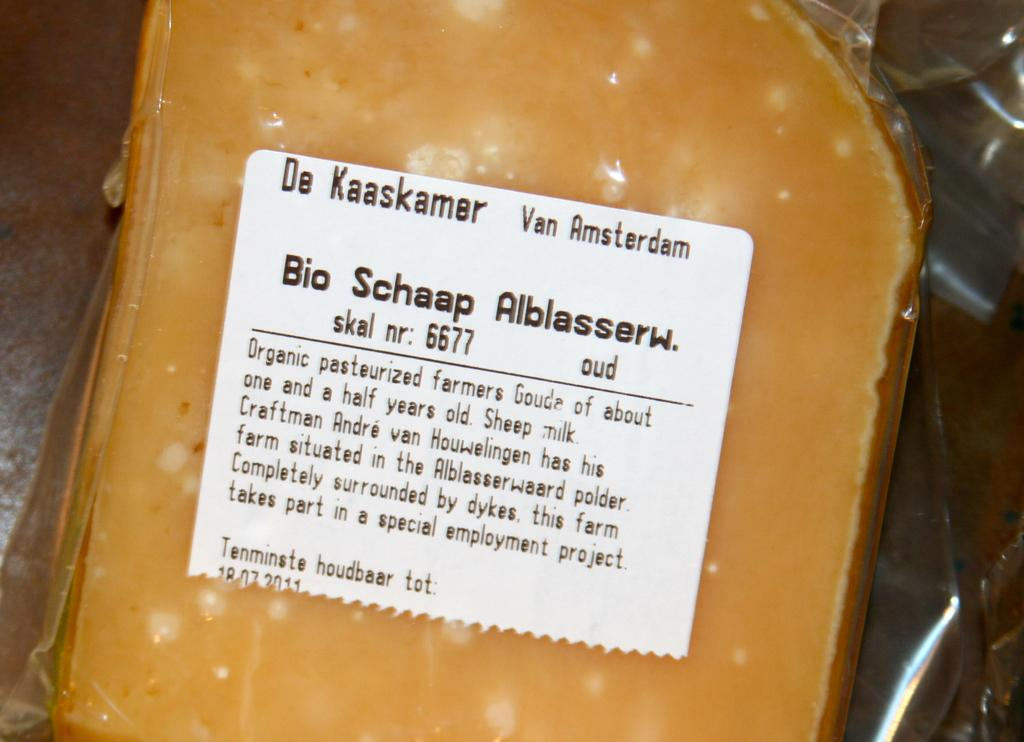What color is the prominent object in the image? The prominent object in the image is yellow. How is the yellow object protected or contained? The yellow object is placed in a transparent cover. Is there any additional information on the transparent cover? Yes, there is a white sticker on the transparent cover. What can be found on the white sticker? The white sticker has text on it. What type of journey does the yellow object take in the image? The image does not depict a journey, and the yellow object is stationary within the transparent cover. 